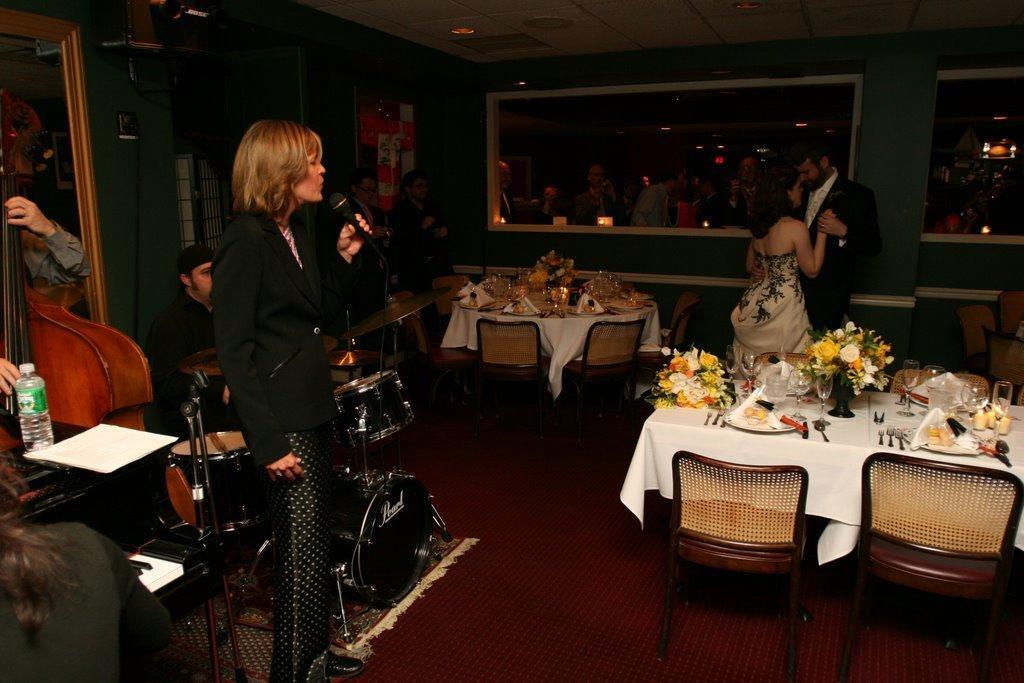In one or two sentences, can you explain what this image depicts? In this picture we can see a room where on left side woman is singing on mic and some persons are playing instruments and here is a bottle over the table and on right side we can see man and woman are dancing looking at each other and we have floor on floor table chairs beside them and on table we can see beautiful decoration with flowers, plates, spoons. 